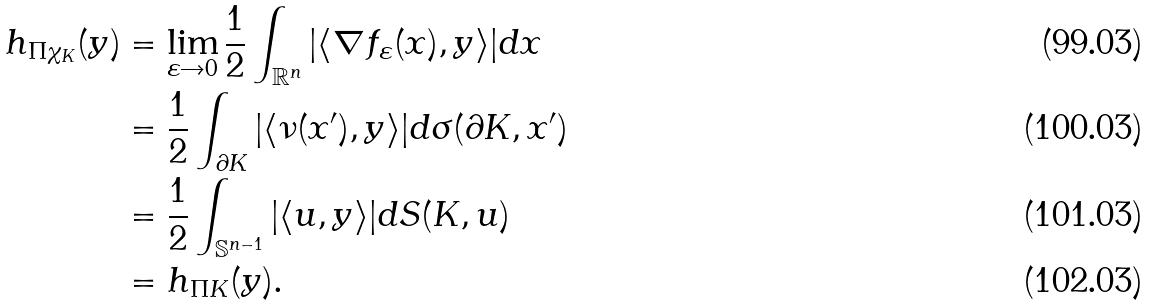<formula> <loc_0><loc_0><loc_500><loc_500>h _ { \Pi \chi _ { K } } ( y ) & = \lim _ { \varepsilon \rightarrow 0 } \frac { 1 } { 2 } \int _ { \mathbb { R } ^ { n } } | \langle \nabla f _ { \varepsilon } ( x ) , y \rangle | d x \\ & = \frac { 1 } { 2 } \int _ { \partial K } | \langle \nu ( x ^ { \prime } ) , y \rangle | d \sigma ( \partial K , x ^ { \prime } ) \\ & = \frac { 1 } { 2 } \int _ { \mathbb { S } ^ { n - 1 } } | \langle u , y \rangle | d S ( K , u ) \\ & = h _ { \Pi K } ( y ) .</formula> 